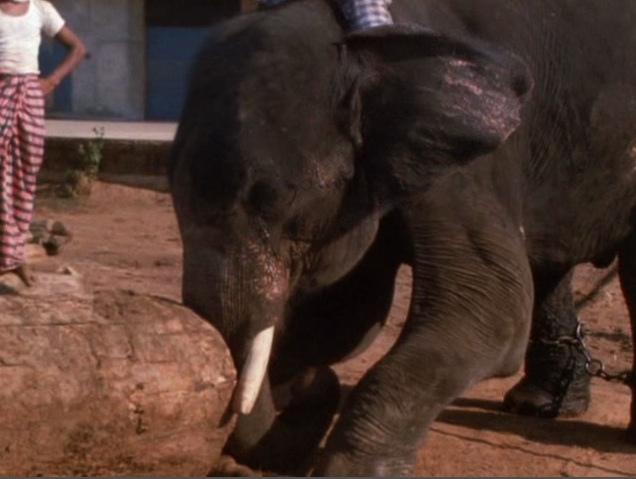Are the men riding the elephants Indians?
Answer briefly. No. Could the horse be towing boarders?
Concise answer only. No. What kind of rock is this?
Be succinct. Not sure. What is the elephant doing?
Short answer required. Kneeling. What is the elephant pushing?
Answer briefly. Log. Is there paint on the elephant?
Keep it brief. No. What animal is present?
Write a very short answer. Elephant. How stressed is the elephant?
Quick response, please. No. Are the elephant's tusks long?
Concise answer only. No. Is the elephant being controlled by humans?
Short answer required. Yes. 